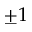<formula> <loc_0><loc_0><loc_500><loc_500>\pm 1</formula> 